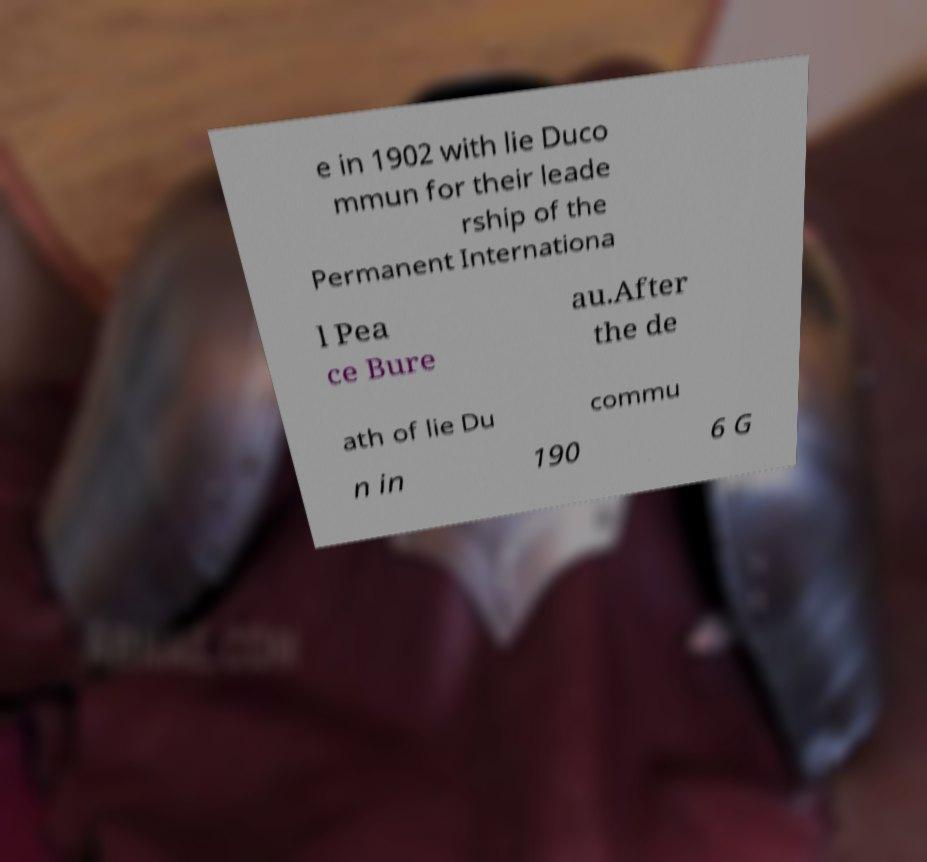There's text embedded in this image that I need extracted. Can you transcribe it verbatim? e in 1902 with lie Duco mmun for their leade rship of the Permanent Internationa l Pea ce Bure au.After the de ath of lie Du commu n in 190 6 G 